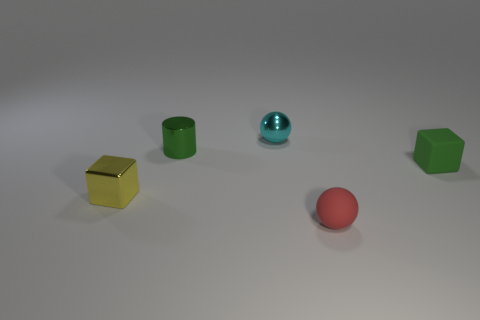Is the tiny block on the right side of the small green shiny cylinder made of the same material as the tiny red object?
Ensure brevity in your answer.  Yes. Is the cyan metallic object the same shape as the small red rubber object?
Your answer should be compact. Yes. There is a cube that is in front of the small green block; how many green metallic objects are in front of it?
Give a very brief answer. 0. What is the material of the other thing that is the same shape as the small green matte object?
Provide a succinct answer. Metal. There is a metallic thing that is left of the cylinder; is it the same color as the tiny shiny cylinder?
Your answer should be very brief. No. Is the cylinder made of the same material as the tiny block to the right of the yellow cube?
Keep it short and to the point. No. The small green thing on the right side of the red object has what shape?
Ensure brevity in your answer.  Cube. How many other objects are there of the same material as the tiny red sphere?
Your answer should be compact. 1. How big is the green metal cylinder?
Give a very brief answer. Small. What number of other objects are the same color as the matte ball?
Provide a succinct answer. 0. 